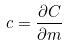<formula> <loc_0><loc_0><loc_500><loc_500>c = \frac { \partial C } { \partial m }</formula> 